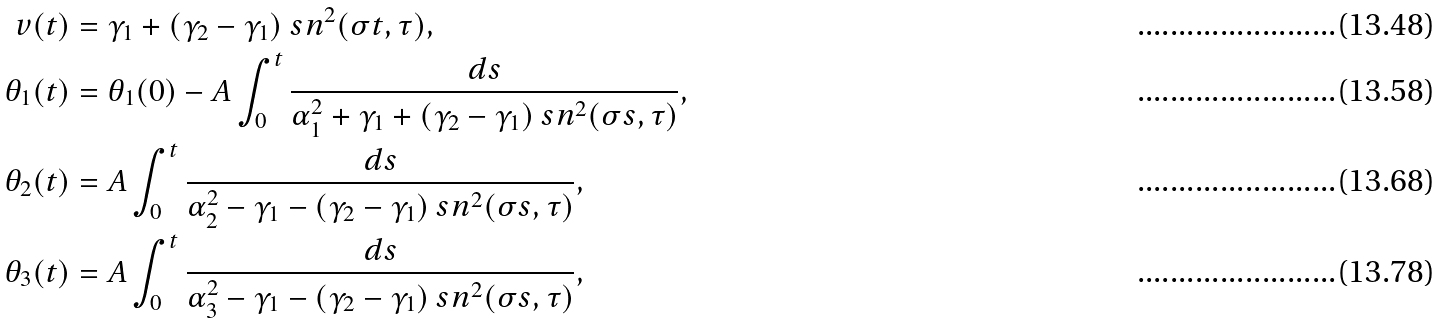Convert formula to latex. <formula><loc_0><loc_0><loc_500><loc_500>v ( t ) & = \gamma _ { 1 } + ( \gamma _ { 2 } - \gamma _ { 1 } ) \ s n ^ { 2 } ( \sigma t , \tau ) , \\ \theta _ { 1 } ( t ) & = \theta _ { 1 } ( 0 ) - A \int _ { 0 } ^ { t } \frac { d s } { \alpha _ { 1 } ^ { 2 } + \gamma _ { 1 } + ( \gamma _ { 2 } - \gamma _ { 1 } ) \ s n ^ { 2 } ( \sigma s , \tau ) } , \\ \theta _ { 2 } ( t ) & = A \int _ { 0 } ^ { t } \frac { d s } { \alpha _ { 2 } ^ { 2 } - \gamma _ { 1 } - ( \gamma _ { 2 } - \gamma _ { 1 } ) \ s n ^ { 2 } ( \sigma s , \tau ) } , \\ \theta _ { 3 } ( t ) & = A \int _ { 0 } ^ { t } \frac { d s } { \alpha _ { 3 } ^ { 2 } - \gamma _ { 1 } - ( \gamma _ { 2 } - \gamma _ { 1 } ) \ s n ^ { 2 } ( \sigma s , \tau ) } ,</formula> 